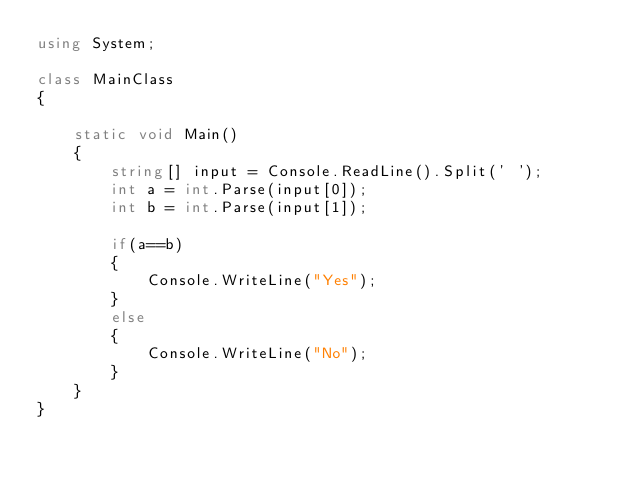Convert code to text. <code><loc_0><loc_0><loc_500><loc_500><_C#_>using System;

class MainClass
{

    static void Main()
    {
        string[] input = Console.ReadLine().Split(' ');
        int a = int.Parse(input[0]);
        int b = int.Parse(input[1]);

        if(a==b)
        {
            Console.WriteLine("Yes");
        }
        else
        {
            Console.WriteLine("No");
        }
    }
}</code> 